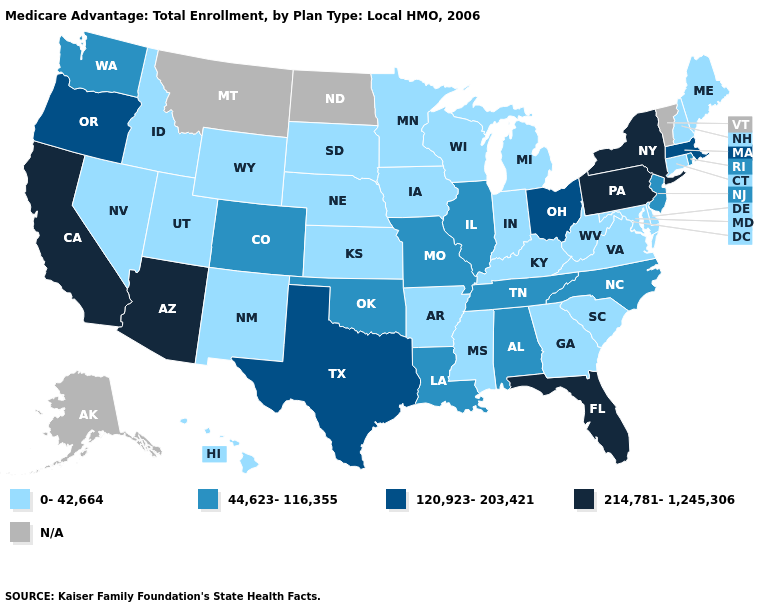Which states have the lowest value in the USA?
Quick response, please. Arkansas, Connecticut, Delaware, Georgia, Hawaii, Iowa, Idaho, Indiana, Kansas, Kentucky, Maryland, Maine, Michigan, Minnesota, Mississippi, Nebraska, New Hampshire, New Mexico, Nevada, South Carolina, South Dakota, Utah, Virginia, Wisconsin, West Virginia, Wyoming. Does the map have missing data?
Write a very short answer. Yes. Does New Hampshire have the highest value in the USA?
Answer briefly. No. What is the lowest value in the Northeast?
Write a very short answer. 0-42,664. Does Illinois have the highest value in the USA?
Give a very brief answer. No. Among the states that border Maryland , does Delaware have the lowest value?
Concise answer only. Yes. Is the legend a continuous bar?
Be succinct. No. Name the states that have a value in the range 0-42,664?
Concise answer only. Arkansas, Connecticut, Delaware, Georgia, Hawaii, Iowa, Idaho, Indiana, Kansas, Kentucky, Maryland, Maine, Michigan, Minnesota, Mississippi, Nebraska, New Hampshire, New Mexico, Nevada, South Carolina, South Dakota, Utah, Virginia, Wisconsin, West Virginia, Wyoming. What is the value of New Jersey?
Write a very short answer. 44,623-116,355. Name the states that have a value in the range N/A?
Give a very brief answer. Alaska, Montana, North Dakota, Vermont. What is the value of Illinois?
Write a very short answer. 44,623-116,355. Which states hav the highest value in the West?
Give a very brief answer. Arizona, California. Name the states that have a value in the range 214,781-1,245,306?
Be succinct. Arizona, California, Florida, New York, Pennsylvania. Among the states that border Texas , which have the lowest value?
Quick response, please. Arkansas, New Mexico. Is the legend a continuous bar?
Be succinct. No. 